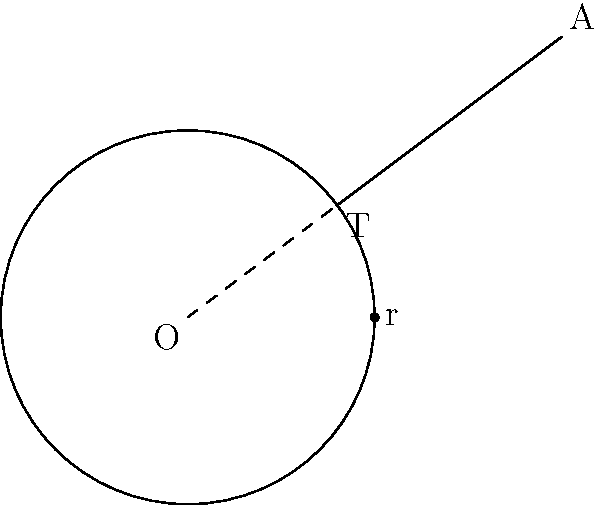In a robotic arm design, a circular gear with radius 2 units is centered at the origin O(0,0). A control point A is located at (4,3). If a tangent line is drawn from point A to the gear, what is the length of this tangent line? Round your answer to two decimal places. Let's approach this step-by-step:

1) First, we need to recognize that the tangent line from an external point to a circle is perpendicular to the radius drawn to the point of tangency. This forms a right triangle.

2) In this right triangle:
   - The hypotenuse is the line OA (from the center to the external point)
   - One leg is the radius of the circle (OT)
   - The other leg is the tangent line we're looking for (AT)

3) We can find the length of OA using the distance formula:
   $$OA = \sqrt{(x_2-x_1)^2 + (y_2-y_1)^2} = \sqrt{(4-0)^2 + (3-0)^2} = \sqrt{16 + 9} = \sqrt{25} = 5$$

4) Now we have a right triangle where:
   - The hypotenuse (OA) is 5
   - One leg (OT, the radius) is 2

5) We can use the Pythagorean theorem to find the length of the tangent line (AT):
   $$OA^2 = OT^2 + AT^2$$
   $$5^2 = 2^2 + AT^2$$
   $$25 = 4 + AT^2$$
   $$AT^2 = 21$$
   $$AT = \sqrt{21}$$

6) Calculate and round to two decimal places:
   $$AT \approx 4.58$$

Therefore, the length of the tangent line is approximately 4.58 units.
Answer: 4.58 units 